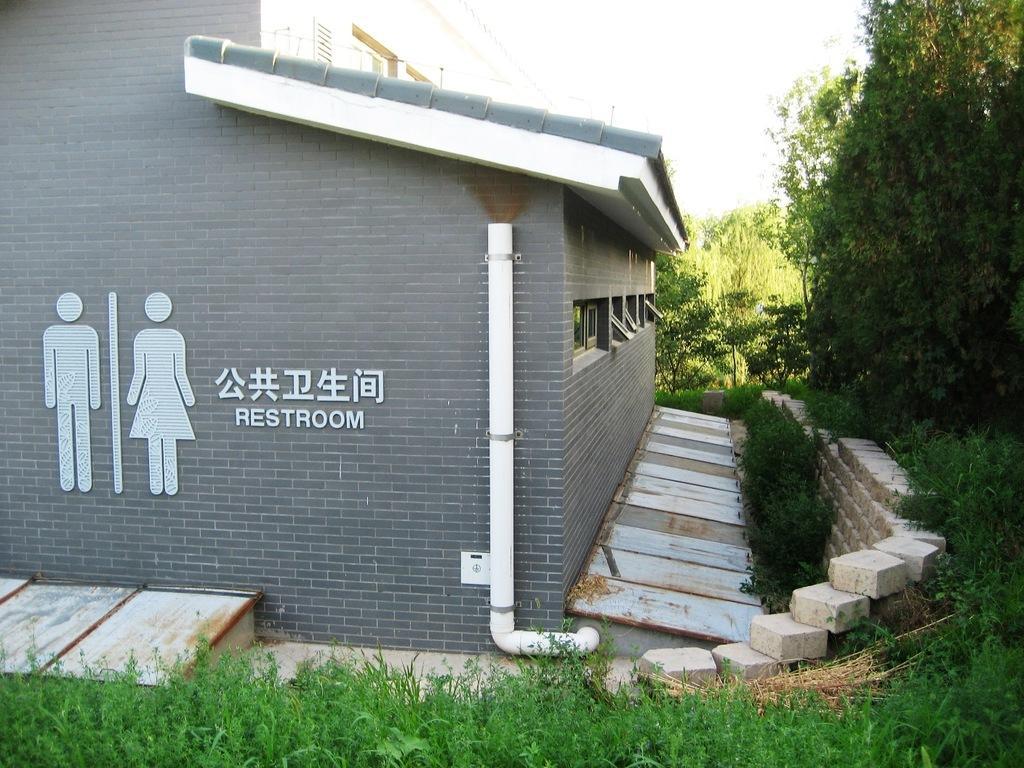Could you give a brief overview of what you see in this image? In this picture I can see a building and text on the wall. I can see trees and a cloudy sky. 